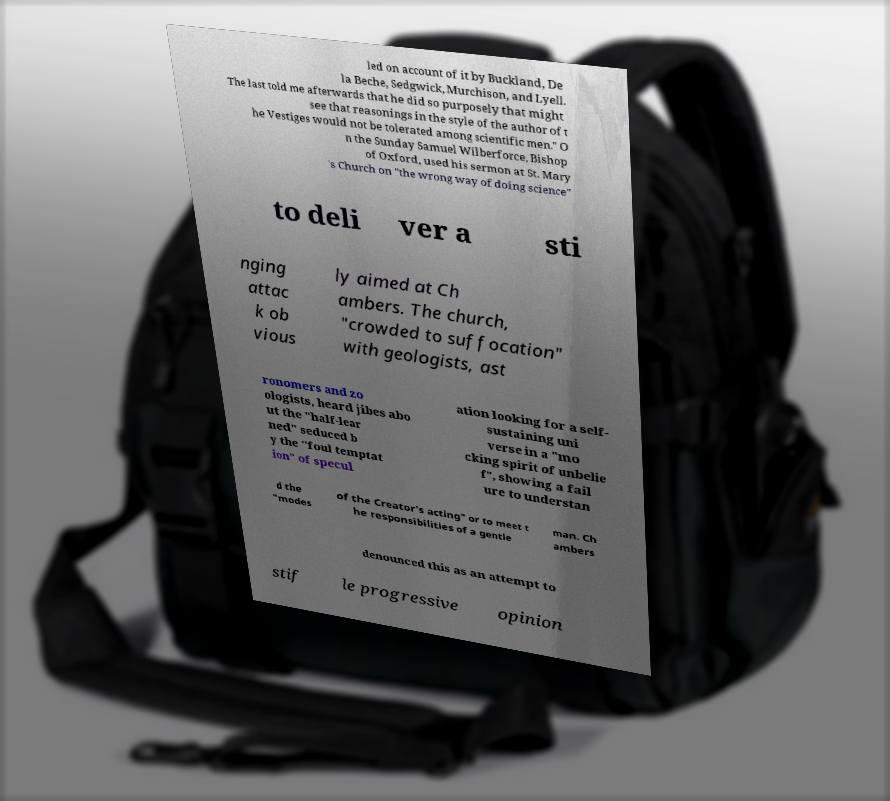Please read and relay the text visible in this image. What does it say? led on account of it by Buckland, De la Beche, Sedgwick, Murchison, and Lyell. The last told me afterwards that he did so purposely that might see that reasonings in the style of the author of t he Vestiges would not be tolerated among scientific men." O n the Sunday Samuel Wilberforce, Bishop of Oxford, used his sermon at St. Mary 's Church on "the wrong way of doing science" to deli ver a sti nging attac k ob vious ly aimed at Ch ambers. The church, "crowded to suffocation" with geologists, ast ronomers and zo ologists, heard jibes abo ut the "half-lear ned" seduced b y the "foul temptat ion" of specul ation looking for a self- sustaining uni verse in a "mo cking spirit of unbelie f", showing a fail ure to understan d the "modes of the Creator's acting" or to meet t he responsibilities of a gentle man. Ch ambers denounced this as an attempt to stif le progressive opinion 